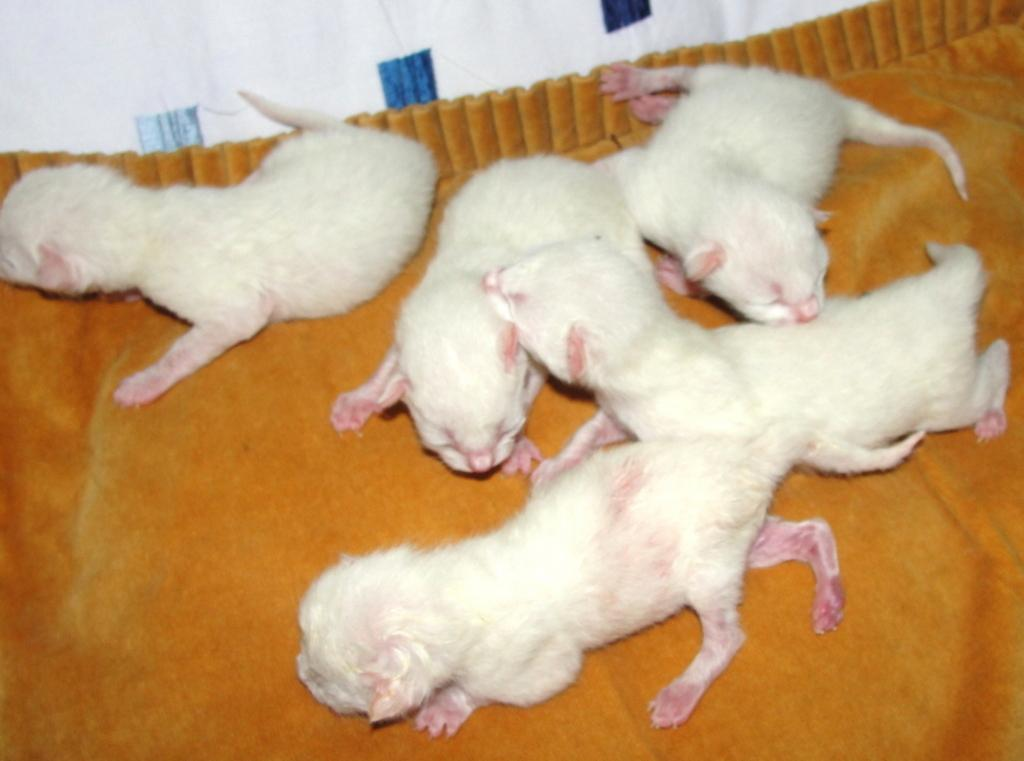What animals are present in the image? There are rats in the image. What can be seen at the bottom of the image? There is an orange and white color cloth at the bottom of the image. What flavor of ice cream is the rat holding in the image? There is no ice cream present in the image, and the rats are not holding anything. 